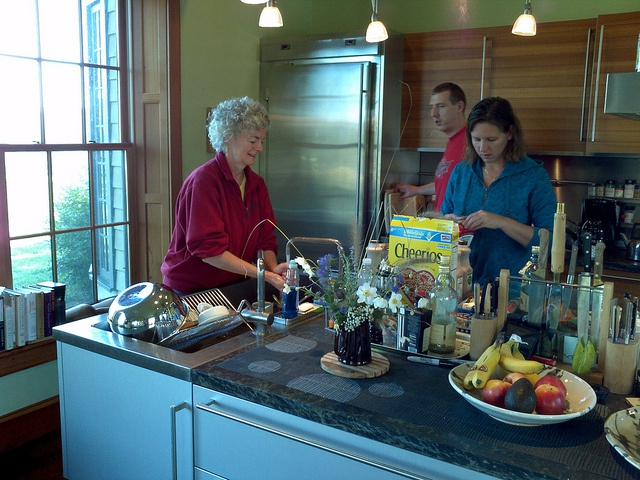Describe the objects in this image and their specific colors. I can see refrigerator in white, teal, black, and purple tones, people in white, maroon, gray, black, and brown tones, people in white, black, darkblue, gray, and blue tones, knife in white, gray, teal, and black tones, and bowl in white, gray, blue, and black tones in this image. 